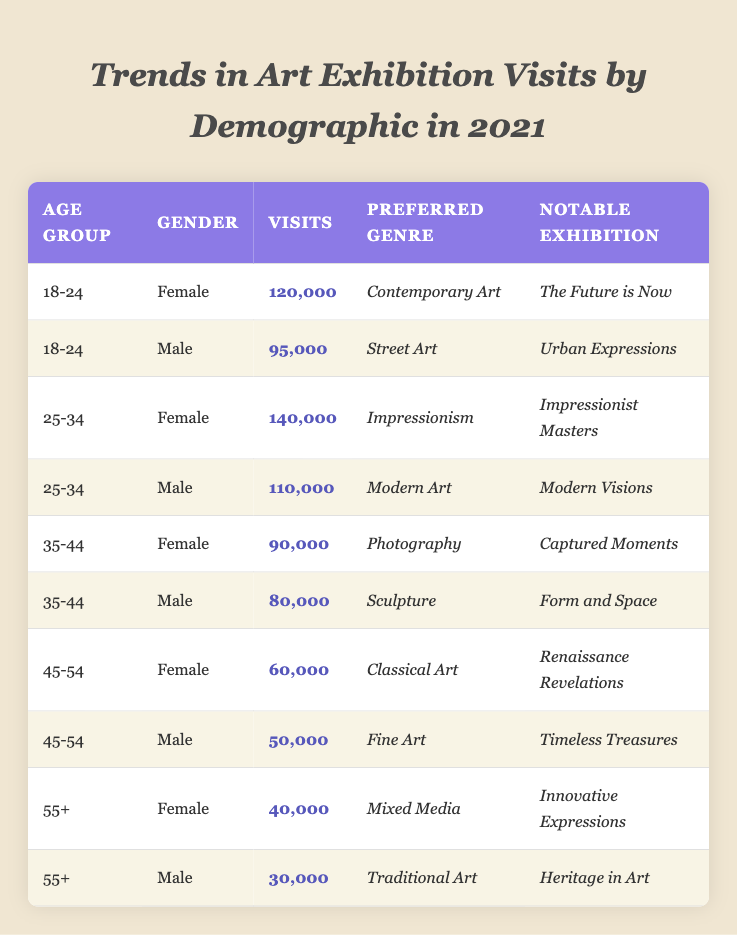What was the notable exhibition for the 25-34 age group female visitors? The table shows that the notable exhibition for female visitors in the 25-34 age group is "Impressionist Masters."
Answer: Impressionist Masters How many visits did males aged 55 and over make to art exhibitions? According to the table, males aged 55 and over made 30,000 visits to art exhibitions.
Answer: 30,000 What is the preferred genre of the male visitors in the 35-44 age group? The table indicates that the preferred genre for male visitors in the 35-44 age group is "Sculpture."
Answer: Sculpture Which age group had the highest total visits? The 25-34 age group had the highest total visits: 140,000 (female) + 110,000 (male) = 250,000.
Answer: 250,000 Is it true that females aged 45-54 visited more exhibitions than males of the same age group? Yes, females aged 45-54 had 60,000 visits while males had 50,000 visits, so females visited more.
Answer: Yes What was the difference in the number of visits between the 18-24 age group females and males? The difference in visits is 120,000 (females) - 95,000 (males) = 25,000.
Answer: 25,000 Which demographic had the least amount of visits? The data shows that males aged 55 and over had the least visits with 30,000.
Answer: Males aged 55+ How many total visits were made by all female visitors across all age groups? To find the total visits by females, add: 120,000 + 140,000 + 90,000 + 60,000 + 40,000 = 450,000.
Answer: 450,000 What is the average number of visits for the 45-54 age group? The average for the 45-54 age group is (60,000 + 50,000) / 2 = 55,000.
Answer: 55,000 What is the percentage of total visits that were made by males in the 25-34 age group? Total visits (1,090,000) = 140,000 (females) + 250,000 (25-34 males) + 80,000 (35-44 males) + 50,000 (45-54 males) + 30,000 (55+ males). The percentage is (110,000/1,090,000) * 100 ≈ 10.1%.
Answer: 10.1% 